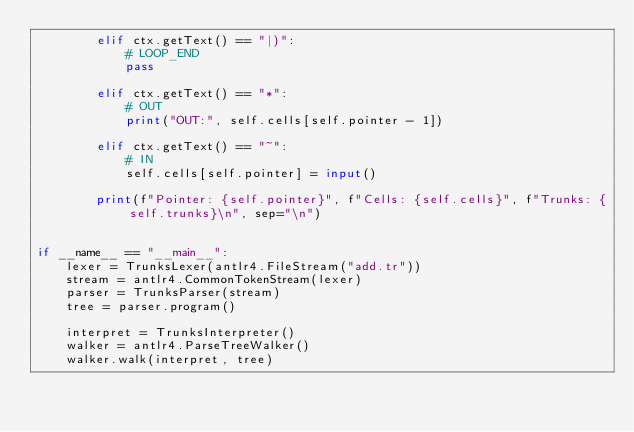<code> <loc_0><loc_0><loc_500><loc_500><_Python_>        elif ctx.getText() == "|)":
            # LOOP_END
            pass

        elif ctx.getText() == "*":
            # OUT
            print("OUT:", self.cells[self.pointer - 1])

        elif ctx.getText() == "~":
            # IN
            self.cells[self.pointer] = input()

        print(f"Pointer: {self.pointer}", f"Cells: {self.cells}", f"Trunks: {self.trunks}\n", sep="\n")


if __name__ == "__main__":
    lexer = TrunksLexer(antlr4.FileStream("add.tr"))
    stream = antlr4.CommonTokenStream(lexer)
    parser = TrunksParser(stream)
    tree = parser.program()

    interpret = TrunksInterpreter()
    walker = antlr4.ParseTreeWalker()
    walker.walk(interpret, tree)
</code> 